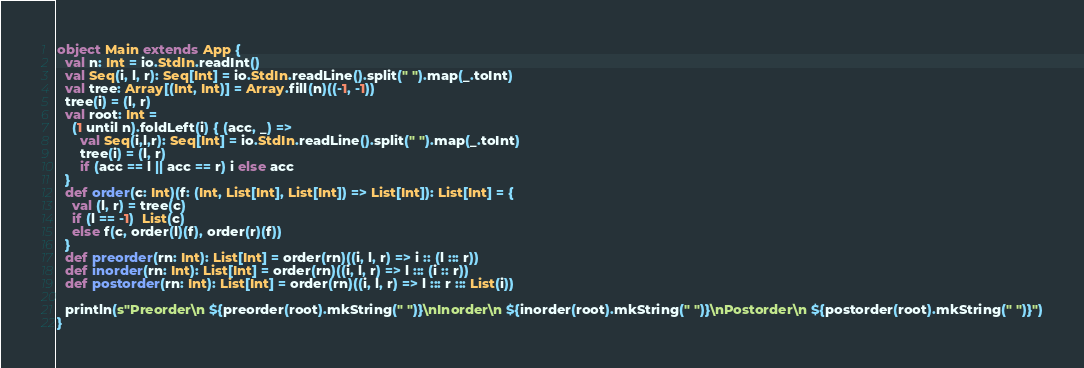<code> <loc_0><loc_0><loc_500><loc_500><_Scala_>object Main extends App {
  val n: Int = io.StdIn.readInt()
  val Seq(i, l, r): Seq[Int] = io.StdIn.readLine().split(" ").map(_.toInt)
  val tree: Array[(Int, Int)] = Array.fill(n)((-1, -1))
  tree(i) = (l, r)
  val root: Int =
    (1 until n).foldLeft(i) { (acc, _) =>
      val Seq(i,l,r): Seq[Int] = io.StdIn.readLine().split(" ").map(_.toInt)
      tree(i) = (l, r)
      if (acc == l || acc == r) i else acc
  }
  def order(c: Int)(f: (Int, List[Int], List[Int]) => List[Int]): List[Int] = {
    val (l, r) = tree(c)
    if (l == -1)  List(c)
    else f(c, order(l)(f), order(r)(f))
  }
  def preorder(rn: Int): List[Int] = order(rn)((i, l, r) => i :: (l ::: r))
  def inorder(rn: Int): List[Int] = order(rn)((i, l, r) => l ::: (i :: r))
  def postorder(rn: Int): List[Int] = order(rn)((i, l, r) => l ::: r ::: List(i))

  println(s"Preorder\n ${preorder(root).mkString(" ")}\nInorder\n ${inorder(root).mkString(" ")}\nPostorder\n ${postorder(root).mkString(" ")}")
}
</code> 